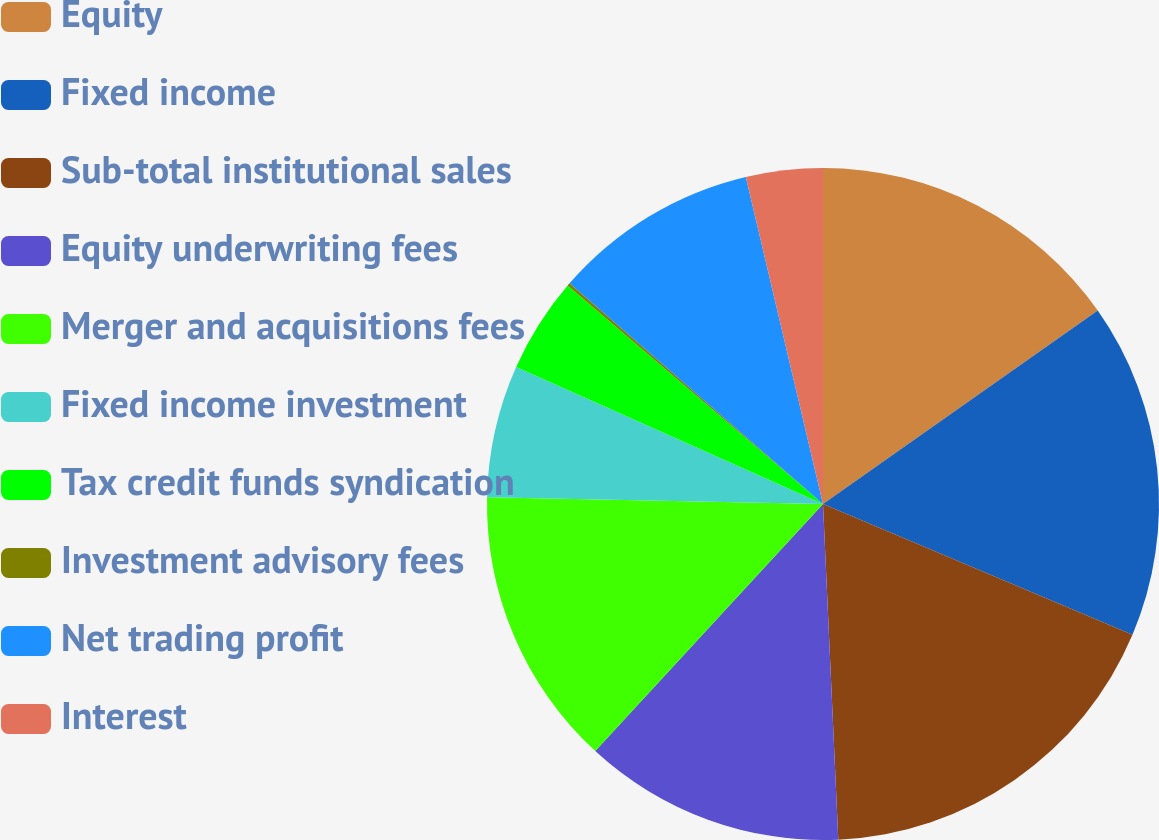Convert chart to OTSL. <chart><loc_0><loc_0><loc_500><loc_500><pie_chart><fcel>Equity<fcel>Fixed income<fcel>Sub-total institutional sales<fcel>Equity underwriting fees<fcel>Merger and acquisitions fees<fcel>Fixed income investment<fcel>Tax credit funds syndication<fcel>Investment advisory fees<fcel>Net trading profit<fcel>Interest<nl><fcel>15.24%<fcel>16.13%<fcel>17.91%<fcel>12.58%<fcel>13.47%<fcel>6.36%<fcel>4.58%<fcel>0.14%<fcel>9.91%<fcel>3.69%<nl></chart> 